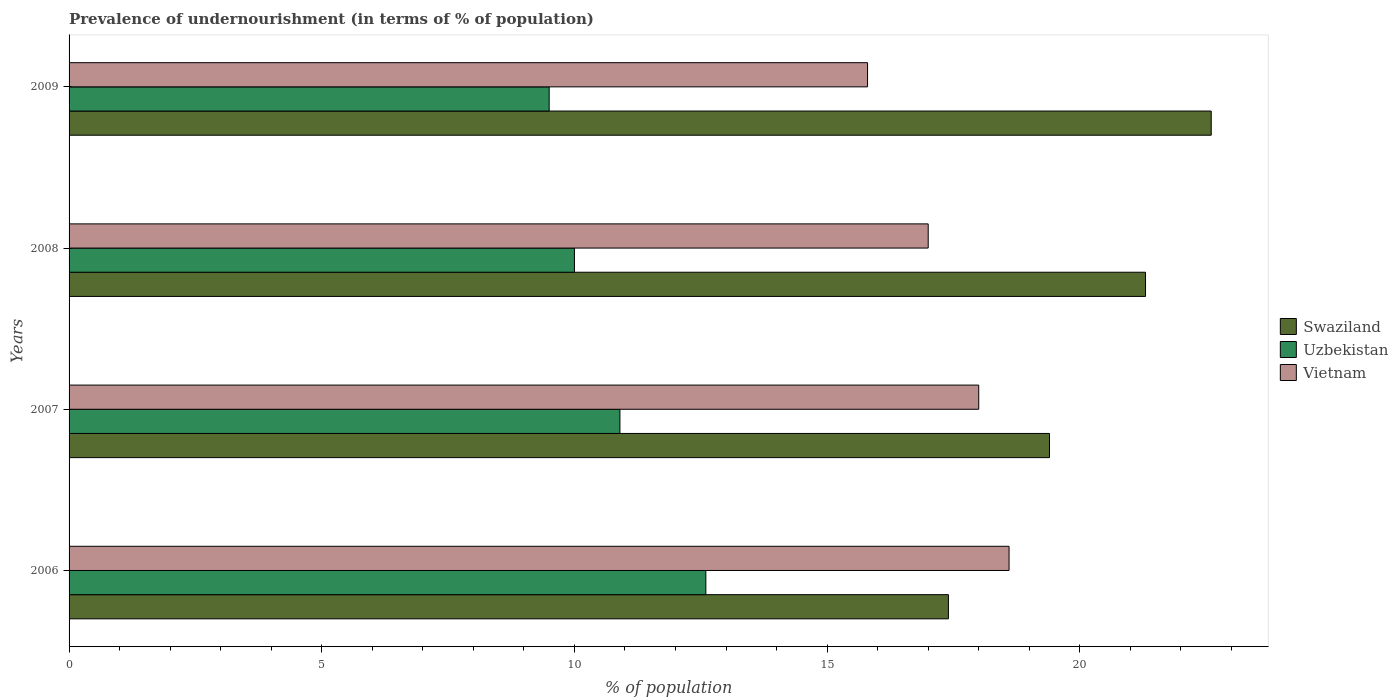How many different coloured bars are there?
Give a very brief answer. 3. Are the number of bars on each tick of the Y-axis equal?
Offer a very short reply. Yes. How many bars are there on the 1st tick from the top?
Your answer should be very brief. 3. What is the label of the 4th group of bars from the top?
Your answer should be compact. 2006. In how many cases, is the number of bars for a given year not equal to the number of legend labels?
Your response must be concise. 0. What is the percentage of undernourished population in Swaziland in 2009?
Your response must be concise. 22.6. Across all years, what is the maximum percentage of undernourished population in Swaziland?
Provide a succinct answer. 22.6. In which year was the percentage of undernourished population in Vietnam maximum?
Your answer should be compact. 2006. What is the difference between the percentage of undernourished population in Swaziland in 2007 and that in 2009?
Provide a succinct answer. -3.2. What is the difference between the percentage of undernourished population in Vietnam in 2006 and the percentage of undernourished population in Uzbekistan in 2009?
Give a very brief answer. 9.1. What is the average percentage of undernourished population in Uzbekistan per year?
Make the answer very short. 10.75. In the year 2009, what is the difference between the percentage of undernourished population in Vietnam and percentage of undernourished population in Swaziland?
Provide a short and direct response. -6.8. In how many years, is the percentage of undernourished population in Swaziland greater than 22 %?
Give a very brief answer. 1. What is the ratio of the percentage of undernourished population in Vietnam in 2007 to that in 2008?
Your answer should be compact. 1.06. What is the difference between the highest and the second highest percentage of undernourished population in Vietnam?
Give a very brief answer. 0.6. What is the difference between the highest and the lowest percentage of undernourished population in Uzbekistan?
Your answer should be very brief. 3.1. In how many years, is the percentage of undernourished population in Swaziland greater than the average percentage of undernourished population in Swaziland taken over all years?
Make the answer very short. 2. What does the 3rd bar from the top in 2007 represents?
Offer a very short reply. Swaziland. What does the 2nd bar from the bottom in 2007 represents?
Offer a terse response. Uzbekistan. Is it the case that in every year, the sum of the percentage of undernourished population in Uzbekistan and percentage of undernourished population in Swaziland is greater than the percentage of undernourished population in Vietnam?
Keep it short and to the point. Yes. How many bars are there?
Your answer should be very brief. 12. Are all the bars in the graph horizontal?
Keep it short and to the point. Yes. How many years are there in the graph?
Provide a succinct answer. 4. Does the graph contain any zero values?
Offer a terse response. No. Does the graph contain grids?
Provide a succinct answer. No. How are the legend labels stacked?
Provide a succinct answer. Vertical. What is the title of the graph?
Provide a short and direct response. Prevalence of undernourishment (in terms of % of population). What is the label or title of the X-axis?
Give a very brief answer. % of population. What is the label or title of the Y-axis?
Provide a succinct answer. Years. What is the % of population in Uzbekistan in 2006?
Keep it short and to the point. 12.6. What is the % of population of Uzbekistan in 2007?
Ensure brevity in your answer.  10.9. What is the % of population in Swaziland in 2008?
Make the answer very short. 21.3. What is the % of population in Vietnam in 2008?
Offer a terse response. 17. What is the % of population in Swaziland in 2009?
Your response must be concise. 22.6. What is the % of population in Vietnam in 2009?
Your response must be concise. 15.8. Across all years, what is the maximum % of population of Swaziland?
Provide a short and direct response. 22.6. Across all years, what is the maximum % of population of Uzbekistan?
Make the answer very short. 12.6. Across all years, what is the minimum % of population of Vietnam?
Give a very brief answer. 15.8. What is the total % of population of Swaziland in the graph?
Your answer should be very brief. 80.7. What is the total % of population in Uzbekistan in the graph?
Ensure brevity in your answer.  43. What is the total % of population in Vietnam in the graph?
Give a very brief answer. 69.4. What is the difference between the % of population of Swaziland in 2006 and that in 2007?
Offer a terse response. -2. What is the difference between the % of population in Vietnam in 2006 and that in 2007?
Your answer should be compact. 0.6. What is the difference between the % of population of Uzbekistan in 2006 and that in 2008?
Ensure brevity in your answer.  2.6. What is the difference between the % of population of Vietnam in 2006 and that in 2009?
Keep it short and to the point. 2.8. What is the difference between the % of population of Swaziland in 2007 and that in 2008?
Ensure brevity in your answer.  -1.9. What is the difference between the % of population of Uzbekistan in 2007 and that in 2008?
Your response must be concise. 0.9. What is the difference between the % of population of Uzbekistan in 2008 and that in 2009?
Your answer should be very brief. 0.5. What is the difference between the % of population of Vietnam in 2008 and that in 2009?
Make the answer very short. 1.2. What is the difference between the % of population in Swaziland in 2006 and the % of population in Uzbekistan in 2008?
Your answer should be very brief. 7.4. What is the difference between the % of population in Swaziland in 2006 and the % of population in Vietnam in 2008?
Keep it short and to the point. 0.4. What is the difference between the % of population of Uzbekistan in 2006 and the % of population of Vietnam in 2008?
Your answer should be compact. -4.4. What is the difference between the % of population of Swaziland in 2006 and the % of population of Uzbekistan in 2009?
Ensure brevity in your answer.  7.9. What is the difference between the % of population in Swaziland in 2006 and the % of population in Vietnam in 2009?
Give a very brief answer. 1.6. What is the difference between the % of population in Swaziland in 2007 and the % of population in Uzbekistan in 2008?
Your answer should be compact. 9.4. What is the difference between the % of population in Swaziland in 2007 and the % of population in Vietnam in 2008?
Keep it short and to the point. 2.4. What is the difference between the % of population of Uzbekistan in 2007 and the % of population of Vietnam in 2009?
Provide a succinct answer. -4.9. What is the difference between the % of population in Swaziland in 2008 and the % of population in Vietnam in 2009?
Your answer should be compact. 5.5. What is the difference between the % of population in Uzbekistan in 2008 and the % of population in Vietnam in 2009?
Your response must be concise. -5.8. What is the average % of population in Swaziland per year?
Make the answer very short. 20.18. What is the average % of population of Uzbekistan per year?
Your response must be concise. 10.75. What is the average % of population of Vietnam per year?
Provide a short and direct response. 17.35. In the year 2006, what is the difference between the % of population in Swaziland and % of population in Vietnam?
Your response must be concise. -1.2. In the year 2006, what is the difference between the % of population in Uzbekistan and % of population in Vietnam?
Make the answer very short. -6. In the year 2007, what is the difference between the % of population in Swaziland and % of population in Uzbekistan?
Make the answer very short. 8.5. In the year 2007, what is the difference between the % of population of Swaziland and % of population of Vietnam?
Give a very brief answer. 1.4. In the year 2008, what is the difference between the % of population of Swaziland and % of population of Vietnam?
Provide a short and direct response. 4.3. In the year 2008, what is the difference between the % of population in Uzbekistan and % of population in Vietnam?
Provide a short and direct response. -7. In the year 2009, what is the difference between the % of population of Swaziland and % of population of Uzbekistan?
Offer a terse response. 13.1. In the year 2009, what is the difference between the % of population of Uzbekistan and % of population of Vietnam?
Your response must be concise. -6.3. What is the ratio of the % of population of Swaziland in 2006 to that in 2007?
Provide a succinct answer. 0.9. What is the ratio of the % of population in Uzbekistan in 2006 to that in 2007?
Your response must be concise. 1.16. What is the ratio of the % of population in Vietnam in 2006 to that in 2007?
Offer a very short reply. 1.03. What is the ratio of the % of population of Swaziland in 2006 to that in 2008?
Your answer should be compact. 0.82. What is the ratio of the % of population in Uzbekistan in 2006 to that in 2008?
Provide a succinct answer. 1.26. What is the ratio of the % of population of Vietnam in 2006 to that in 2008?
Your response must be concise. 1.09. What is the ratio of the % of population in Swaziland in 2006 to that in 2009?
Provide a succinct answer. 0.77. What is the ratio of the % of population of Uzbekistan in 2006 to that in 2009?
Keep it short and to the point. 1.33. What is the ratio of the % of population of Vietnam in 2006 to that in 2009?
Your answer should be very brief. 1.18. What is the ratio of the % of population of Swaziland in 2007 to that in 2008?
Offer a very short reply. 0.91. What is the ratio of the % of population of Uzbekistan in 2007 to that in 2008?
Your answer should be compact. 1.09. What is the ratio of the % of population of Vietnam in 2007 to that in 2008?
Give a very brief answer. 1.06. What is the ratio of the % of population in Swaziland in 2007 to that in 2009?
Keep it short and to the point. 0.86. What is the ratio of the % of population in Uzbekistan in 2007 to that in 2009?
Give a very brief answer. 1.15. What is the ratio of the % of population in Vietnam in 2007 to that in 2009?
Ensure brevity in your answer.  1.14. What is the ratio of the % of population of Swaziland in 2008 to that in 2009?
Offer a very short reply. 0.94. What is the ratio of the % of population of Uzbekistan in 2008 to that in 2009?
Keep it short and to the point. 1.05. What is the ratio of the % of population in Vietnam in 2008 to that in 2009?
Your answer should be compact. 1.08. What is the difference between the highest and the lowest % of population of Vietnam?
Provide a short and direct response. 2.8. 